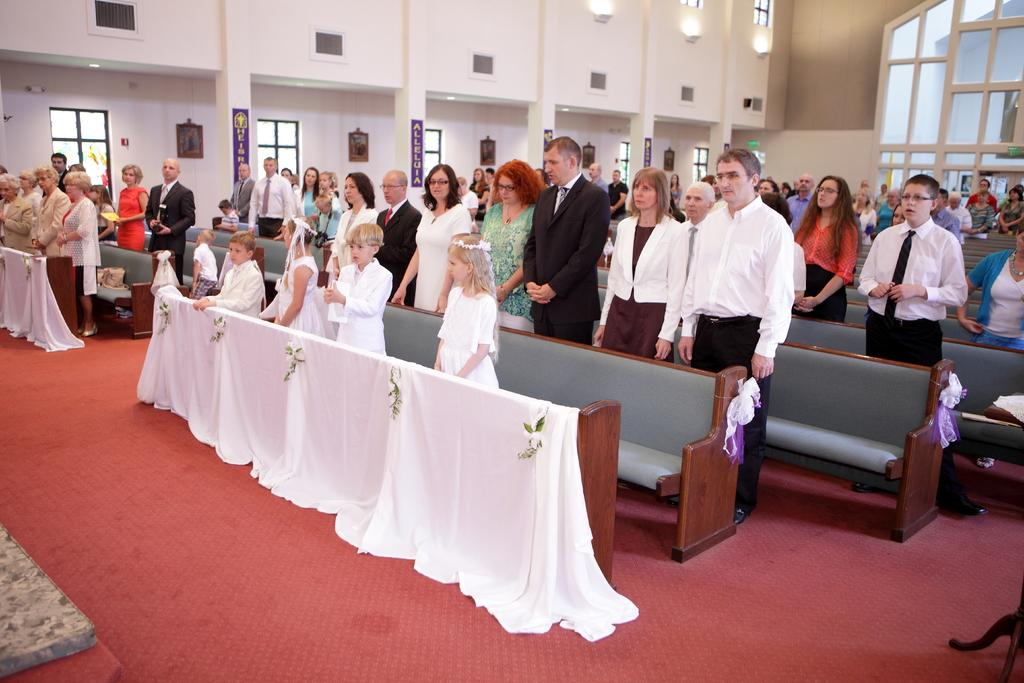What can be seen in the image? There are people standing in the image. Where are the people standing? The people are standing on the floor. What type of furniture is present in the image? There are wooden benches in the image. What can be seen in the background of the image? There is a wall visible in the background of the image. Can you see any goldfish swimming near the people in the image? No, there are no goldfish present in the image. 